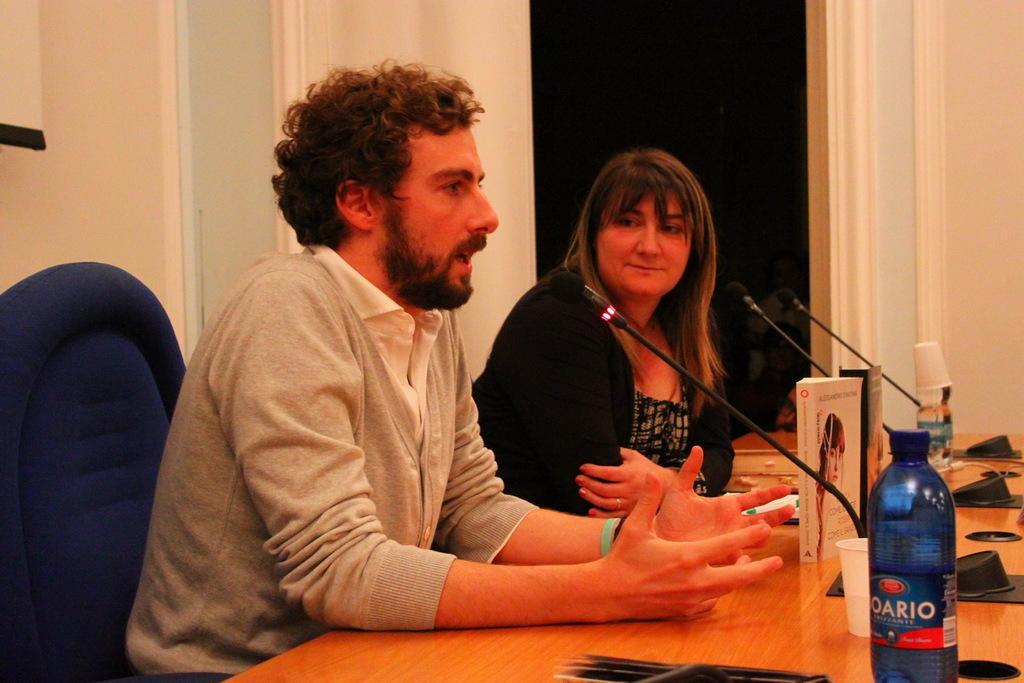Could you give a brief overview of what you see in this image? There is a man and a woman sitting on chair. In front of them there is a table. On the table there are mice, bottles, cups and books. In the back there is a wall. 